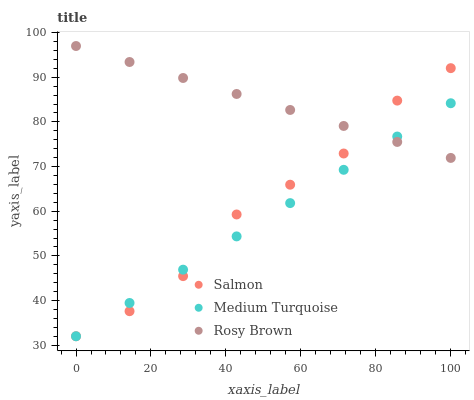Does Medium Turquoise have the minimum area under the curve?
Answer yes or no. Yes. Does Rosy Brown have the maximum area under the curve?
Answer yes or no. Yes. Does Salmon have the minimum area under the curve?
Answer yes or no. No. Does Salmon have the maximum area under the curve?
Answer yes or no. No. Is Medium Turquoise the smoothest?
Answer yes or no. Yes. Is Salmon the roughest?
Answer yes or no. Yes. Is Salmon the smoothest?
Answer yes or no. No. Is Medium Turquoise the roughest?
Answer yes or no. No. Does Salmon have the lowest value?
Answer yes or no. Yes. Does Rosy Brown have the highest value?
Answer yes or no. Yes. Does Salmon have the highest value?
Answer yes or no. No. Does Salmon intersect Medium Turquoise?
Answer yes or no. Yes. Is Salmon less than Medium Turquoise?
Answer yes or no. No. Is Salmon greater than Medium Turquoise?
Answer yes or no. No. 